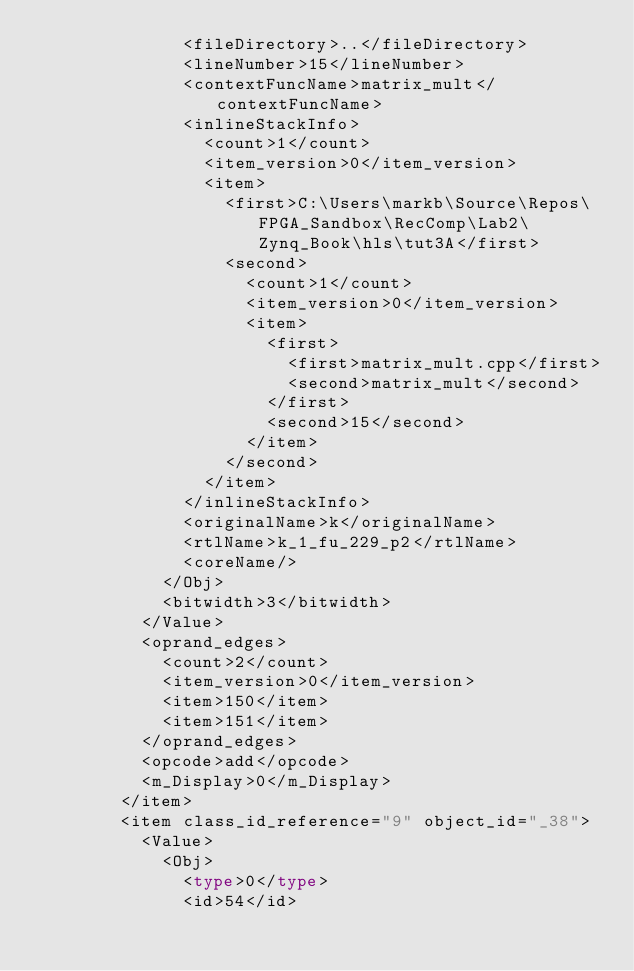Convert code to text. <code><loc_0><loc_0><loc_500><loc_500><_Ada_>              <fileDirectory>..</fileDirectory>
              <lineNumber>15</lineNumber>
              <contextFuncName>matrix_mult</contextFuncName>
              <inlineStackInfo>
                <count>1</count>
                <item_version>0</item_version>
                <item>
                  <first>C:\Users\markb\Source\Repos\FPGA_Sandbox\RecComp\Lab2\Zynq_Book\hls\tut3A</first>
                  <second>
                    <count>1</count>
                    <item_version>0</item_version>
                    <item>
                      <first>
                        <first>matrix_mult.cpp</first>
                        <second>matrix_mult</second>
                      </first>
                      <second>15</second>
                    </item>
                  </second>
                </item>
              </inlineStackInfo>
              <originalName>k</originalName>
              <rtlName>k_1_fu_229_p2</rtlName>
              <coreName/>
            </Obj>
            <bitwidth>3</bitwidth>
          </Value>
          <oprand_edges>
            <count>2</count>
            <item_version>0</item_version>
            <item>150</item>
            <item>151</item>
          </oprand_edges>
          <opcode>add</opcode>
          <m_Display>0</m_Display>
        </item>
        <item class_id_reference="9" object_id="_38">
          <Value>
            <Obj>
              <type>0</type>
              <id>54</id></code> 